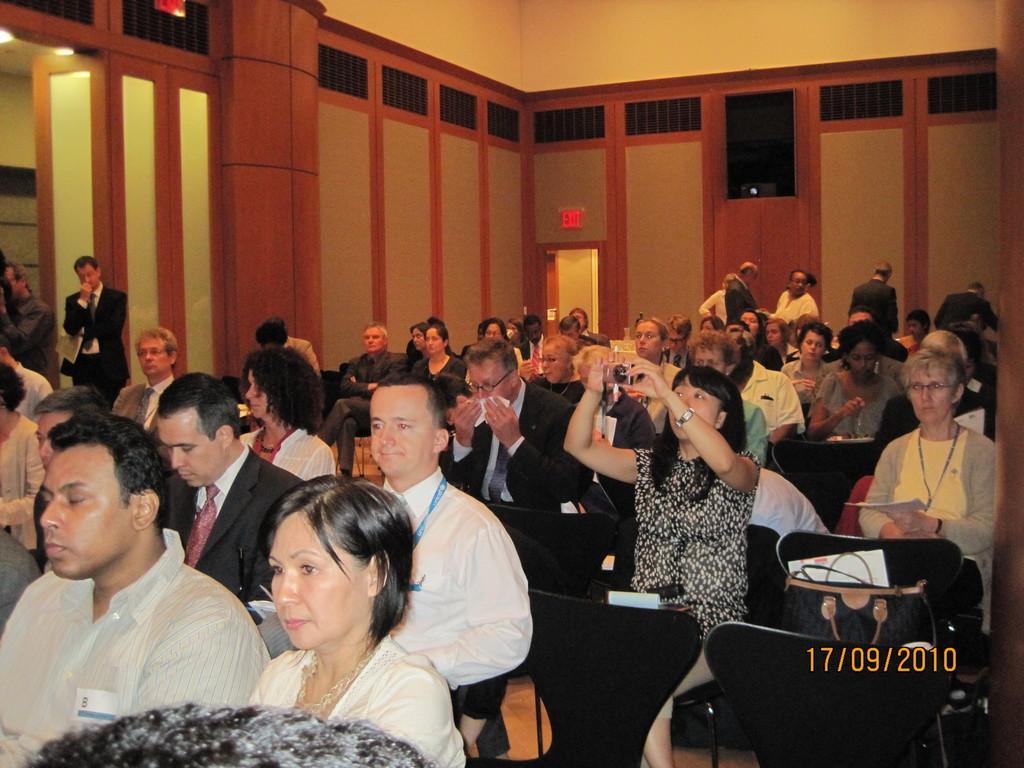Could you give a brief overview of what you see in this image? People are sitting on the chairs. There is a bag at the right. A person is holding a camera. A person is standing at the left. 